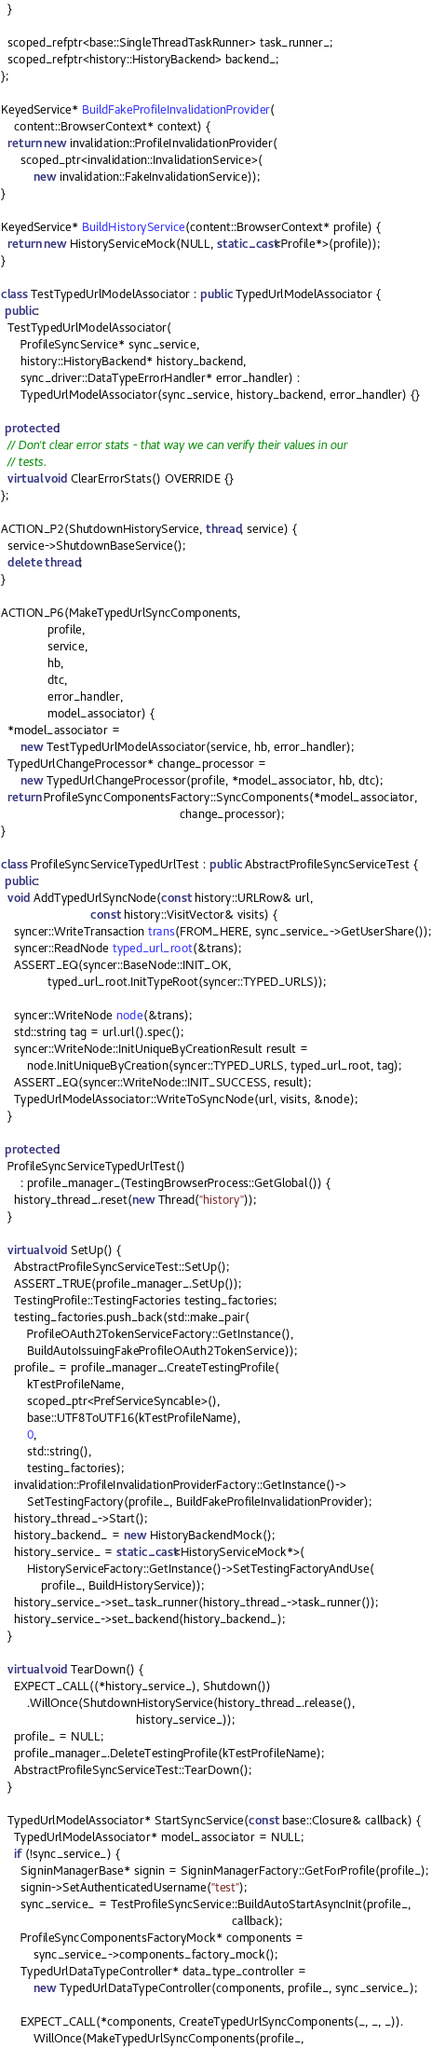Convert code to text. <code><loc_0><loc_0><loc_500><loc_500><_C++_>  }

  scoped_refptr<base::SingleThreadTaskRunner> task_runner_;
  scoped_refptr<history::HistoryBackend> backend_;
};

KeyedService* BuildFakeProfileInvalidationProvider(
    content::BrowserContext* context) {
  return new invalidation::ProfileInvalidationProvider(
      scoped_ptr<invalidation::InvalidationService>(
          new invalidation::FakeInvalidationService));
}

KeyedService* BuildHistoryService(content::BrowserContext* profile) {
  return new HistoryServiceMock(NULL, static_cast<Profile*>(profile));
}

class TestTypedUrlModelAssociator : public TypedUrlModelAssociator {
 public:
  TestTypedUrlModelAssociator(
      ProfileSyncService* sync_service,
      history::HistoryBackend* history_backend,
      sync_driver::DataTypeErrorHandler* error_handler) :
      TypedUrlModelAssociator(sync_service, history_backend, error_handler) {}

 protected:
  // Don't clear error stats - that way we can verify their values in our
  // tests.
  virtual void ClearErrorStats() OVERRIDE {}
};

ACTION_P2(ShutdownHistoryService, thread, service) {
  service->ShutdownBaseService();
  delete thread;
}

ACTION_P6(MakeTypedUrlSyncComponents,
              profile,
              service,
              hb,
              dtc,
              error_handler,
              model_associator) {
  *model_associator =
      new TestTypedUrlModelAssociator(service, hb, error_handler);
  TypedUrlChangeProcessor* change_processor =
      new TypedUrlChangeProcessor(profile, *model_associator, hb, dtc);
  return ProfileSyncComponentsFactory::SyncComponents(*model_associator,
                                                      change_processor);
}

class ProfileSyncServiceTypedUrlTest : public AbstractProfileSyncServiceTest {
 public:
  void AddTypedUrlSyncNode(const history::URLRow& url,
                           const history::VisitVector& visits) {
    syncer::WriteTransaction trans(FROM_HERE, sync_service_->GetUserShare());
    syncer::ReadNode typed_url_root(&trans);
    ASSERT_EQ(syncer::BaseNode::INIT_OK,
              typed_url_root.InitTypeRoot(syncer::TYPED_URLS));

    syncer::WriteNode node(&trans);
    std::string tag = url.url().spec();
    syncer::WriteNode::InitUniqueByCreationResult result =
        node.InitUniqueByCreation(syncer::TYPED_URLS, typed_url_root, tag);
    ASSERT_EQ(syncer::WriteNode::INIT_SUCCESS, result);
    TypedUrlModelAssociator::WriteToSyncNode(url, visits, &node);
  }

 protected:
  ProfileSyncServiceTypedUrlTest()
      : profile_manager_(TestingBrowserProcess::GetGlobal()) {
    history_thread_.reset(new Thread("history"));
  }

  virtual void SetUp() {
    AbstractProfileSyncServiceTest::SetUp();
    ASSERT_TRUE(profile_manager_.SetUp());
    TestingProfile::TestingFactories testing_factories;
    testing_factories.push_back(std::make_pair(
        ProfileOAuth2TokenServiceFactory::GetInstance(),
        BuildAutoIssuingFakeProfileOAuth2TokenService));
    profile_ = profile_manager_.CreateTestingProfile(
        kTestProfileName,
        scoped_ptr<PrefServiceSyncable>(),
        base::UTF8ToUTF16(kTestProfileName),
        0,
        std::string(),
        testing_factories);
    invalidation::ProfileInvalidationProviderFactory::GetInstance()->
        SetTestingFactory(profile_, BuildFakeProfileInvalidationProvider);
    history_thread_->Start();
    history_backend_ = new HistoryBackendMock();
    history_service_ = static_cast<HistoryServiceMock*>(
        HistoryServiceFactory::GetInstance()->SetTestingFactoryAndUse(
            profile_, BuildHistoryService));
    history_service_->set_task_runner(history_thread_->task_runner());
    history_service_->set_backend(history_backend_);
  }

  virtual void TearDown() {
    EXPECT_CALL((*history_service_), Shutdown())
        .WillOnce(ShutdownHistoryService(history_thread_.release(),
                                         history_service_));
    profile_ = NULL;
    profile_manager_.DeleteTestingProfile(kTestProfileName);
    AbstractProfileSyncServiceTest::TearDown();
  }

  TypedUrlModelAssociator* StartSyncService(const base::Closure& callback) {
    TypedUrlModelAssociator* model_associator = NULL;
    if (!sync_service_) {
      SigninManagerBase* signin = SigninManagerFactory::GetForProfile(profile_);
      signin->SetAuthenticatedUsername("test");
      sync_service_ = TestProfileSyncService::BuildAutoStartAsyncInit(profile_,
                                                                      callback);
      ProfileSyncComponentsFactoryMock* components =
          sync_service_->components_factory_mock();
      TypedUrlDataTypeController* data_type_controller =
          new TypedUrlDataTypeController(components, profile_, sync_service_);

      EXPECT_CALL(*components, CreateTypedUrlSyncComponents(_, _, _)).
          WillOnce(MakeTypedUrlSyncComponents(profile_,</code> 